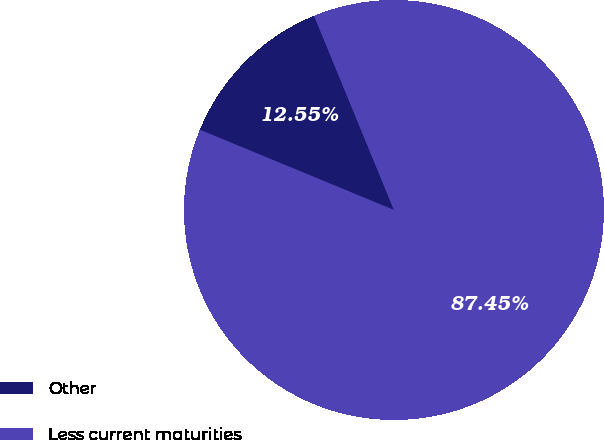Convert chart. <chart><loc_0><loc_0><loc_500><loc_500><pie_chart><fcel>Other<fcel>Less current maturities<nl><fcel>12.55%<fcel>87.45%<nl></chart> 